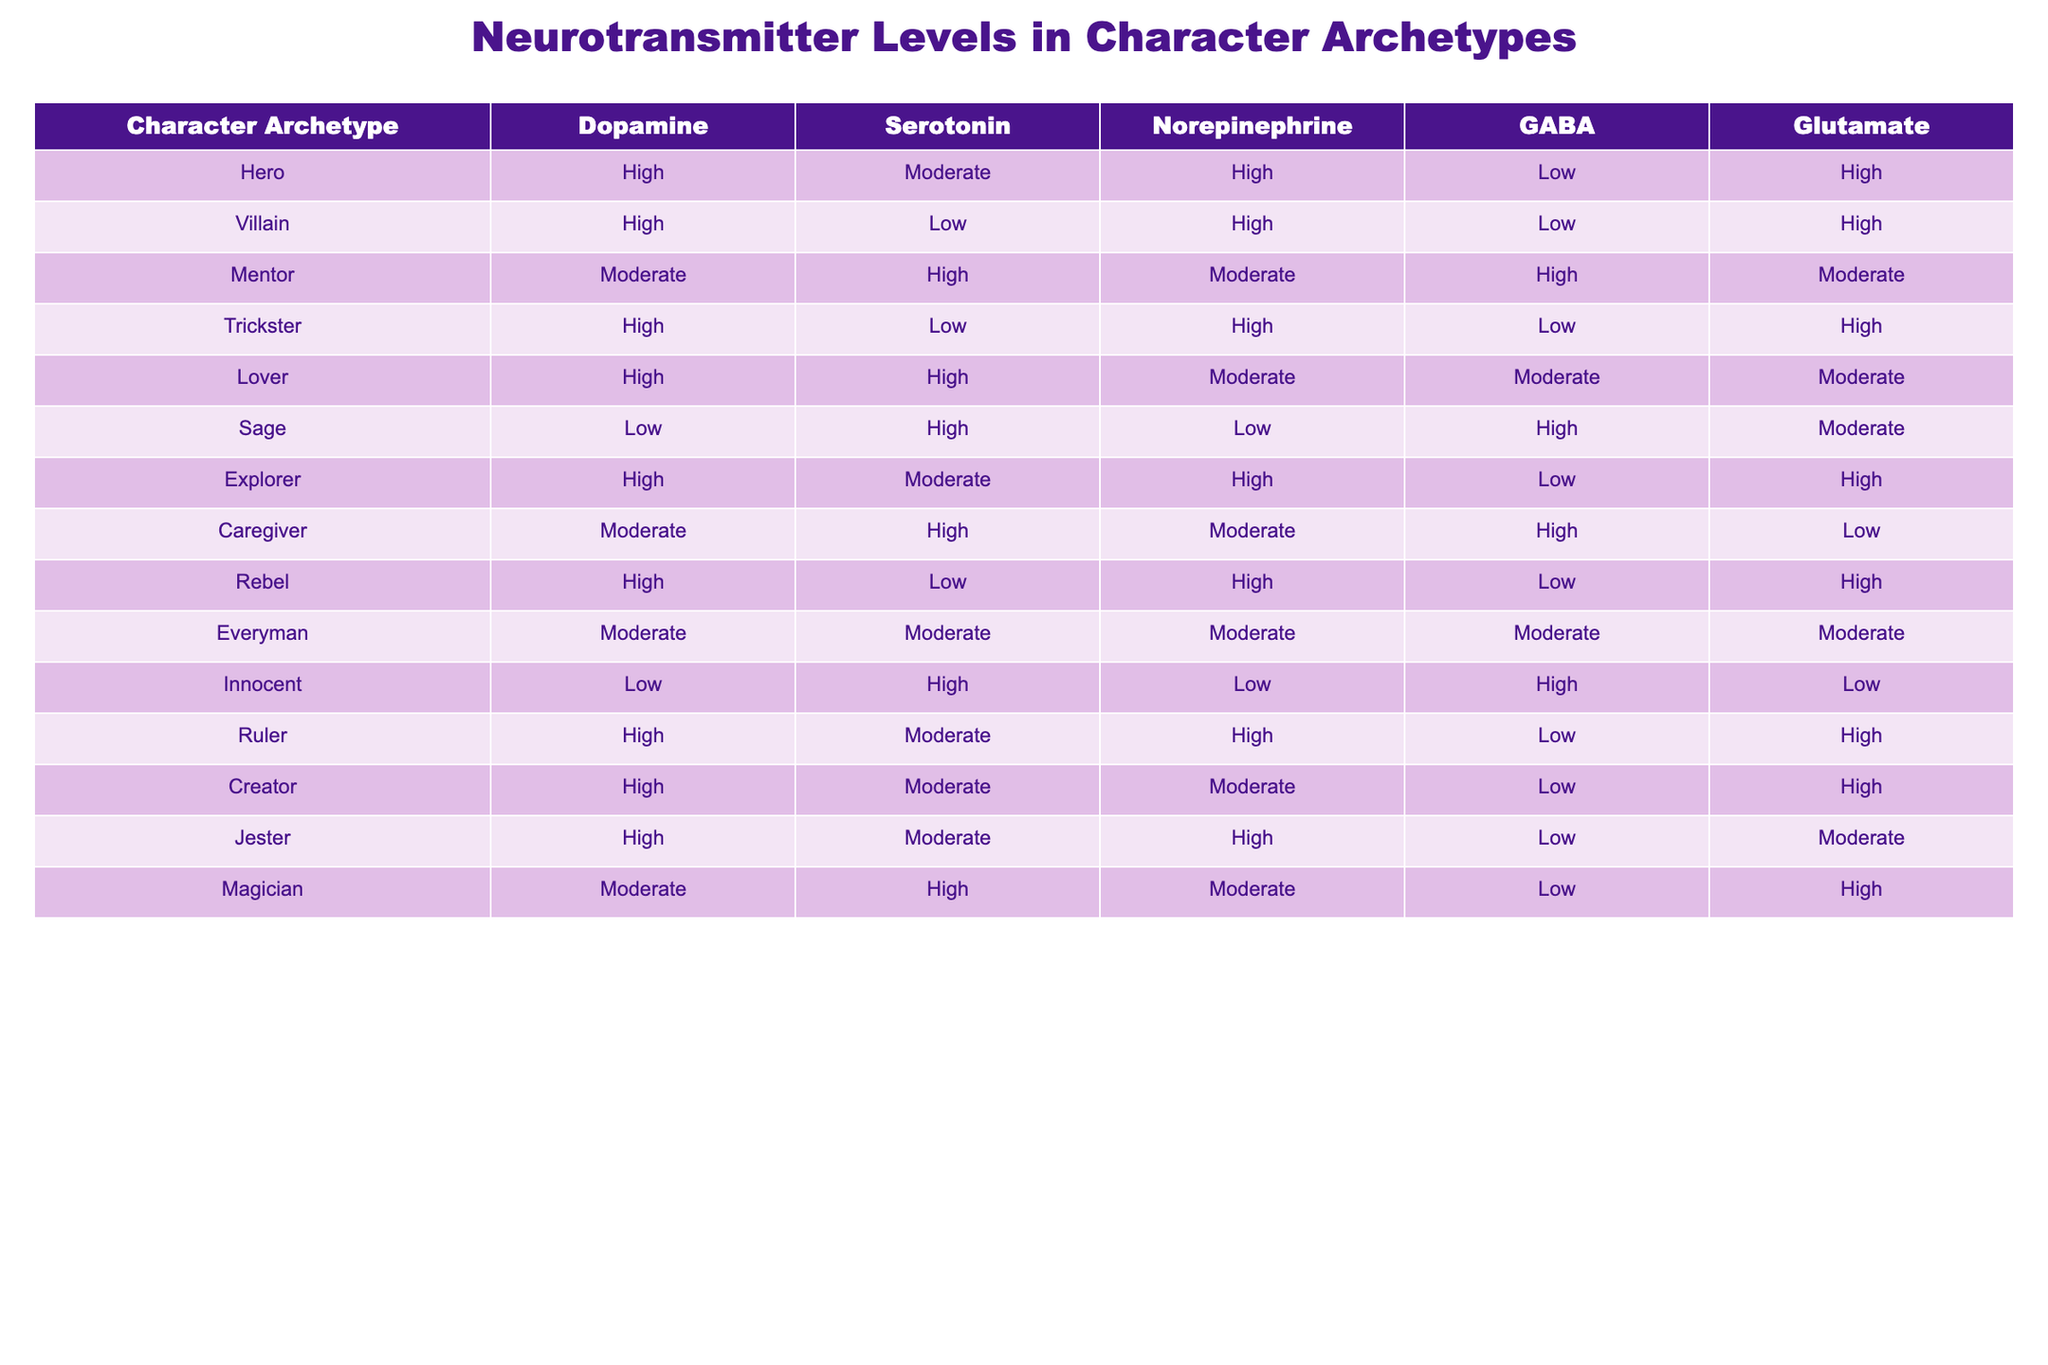What is the serotonin level for the Lover archetype? From the table, the serotonin level for the Lover archetype is listed directly under the Serotonin column. The value is High.
Answer: High Which character archetype has the lowest GABA level? By examining the GABA column, we find that both the Hero and Villain archetypes have a Low level of GABA, but they are not the only ones. We check all entries, and the Innocent archetype also has a Low level. Since we are looking for the one with the lowest, multiple archetypes tie for the lowest GABA.
Answer: Hero, Villain, Innocent How many archetypes have a High level of Glutamate? We count the instances of High in the Glutamate column. The Hero, Villain, Explorer, Ruler, Creator, and Jester all have High levels. This gives us a total of 6 archetypes.
Answer: 6 Does the Sage archetype have a higher serotonin level than the Rebel archetype? The Sage has a High level of serotonin, which can be directly compared to the Rebel's Low level of serotonin from the table. Thus, the Sage does have a higher serotonin level than the Rebel.
Answer: Yes What is the average level of dopamine across all character archetypes? The dopamine levels are High (8 instances), Moderate (3 instances), and Low (2 instances) across 13 archetypes. To quantify, we can assign values: High=2, Moderate=1, Low=0. Calculating gives us (8*2 + 3*1 + 2*0) / 13 = (16 + 3 + 0) / 13 = 19 / 13 ≈ 1.46. Rounding down based on qualitative assessment gives us a final dopamine level of Moderate.
Answer: Moderate 